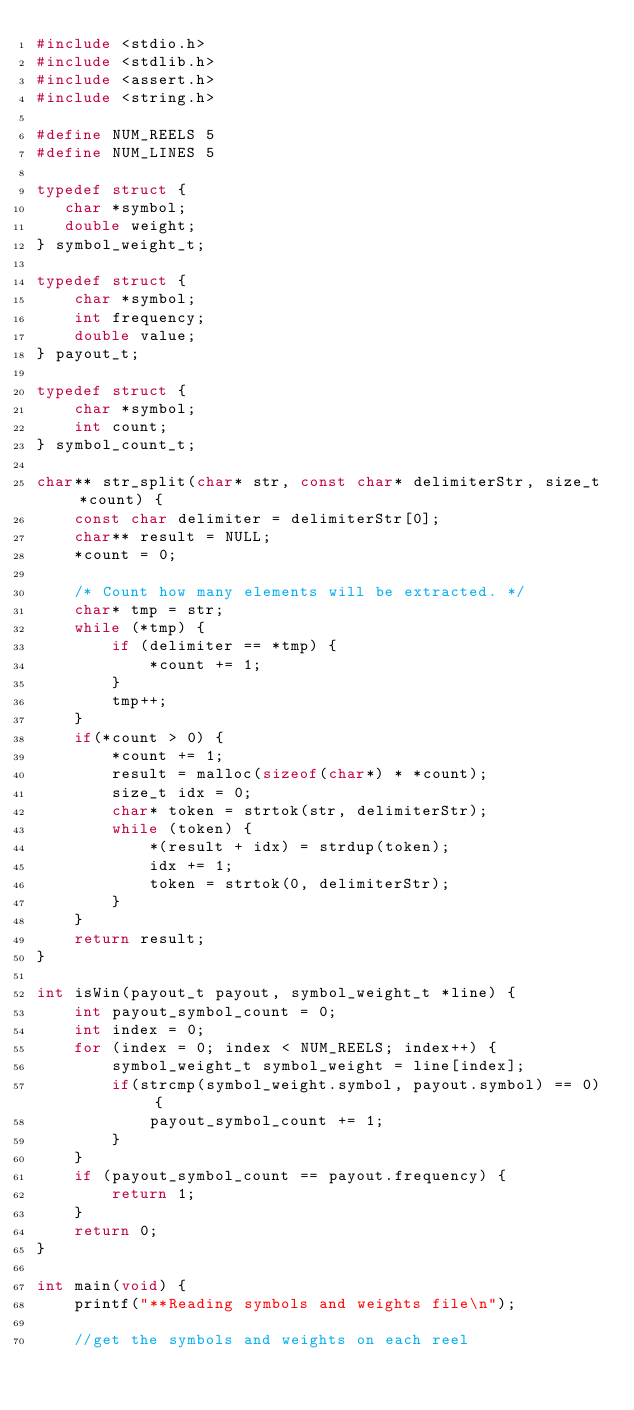<code> <loc_0><loc_0><loc_500><loc_500><_C_>#include <stdio.h>
#include <stdlib.h>
#include <assert.h>
#include <string.h>

#define NUM_REELS 5
#define NUM_LINES 5

typedef struct {
   char *symbol;
   double weight;
} symbol_weight_t;

typedef struct {
    char *symbol;
    int frequency;
    double value;
} payout_t;

typedef struct {
    char *symbol;
    int count;
} symbol_count_t;

char** str_split(char* str, const char* delimiterStr, size_t *count) {
    const char delimiter = delimiterStr[0];
    char** result = NULL;
    *count = 0;

    /* Count how many elements will be extracted. */
    char* tmp = str;
    while (*tmp) {
        if (delimiter == *tmp) {
            *count += 1;
        }
        tmp++;
    }
    if(*count > 0) {
        *count += 1;
        result = malloc(sizeof(char*) * *count);
        size_t idx = 0;
        char* token = strtok(str, delimiterStr);
        while (token) {
            *(result + idx) = strdup(token);
            idx += 1;
            token = strtok(0, delimiterStr);
        }
    }
    return result;
}

int isWin(payout_t payout, symbol_weight_t *line) {
    int payout_symbol_count = 0;
    int index = 0;
    for (index = 0; index < NUM_REELS; index++) {
        symbol_weight_t symbol_weight = line[index];
        if(strcmp(symbol_weight.symbol, payout.symbol) == 0) {
            payout_symbol_count += 1;
        }
    }
    if (payout_symbol_count == payout.frequency) {
        return 1;
    }
    return 0;
}

int main(void) {
    printf("**Reading symbols and weights file\n");

    //get the symbols and weights on each reel</code> 